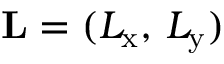<formula> <loc_0><loc_0><loc_500><loc_500>L = ( L _ { x } , \, L _ { y } )</formula> 